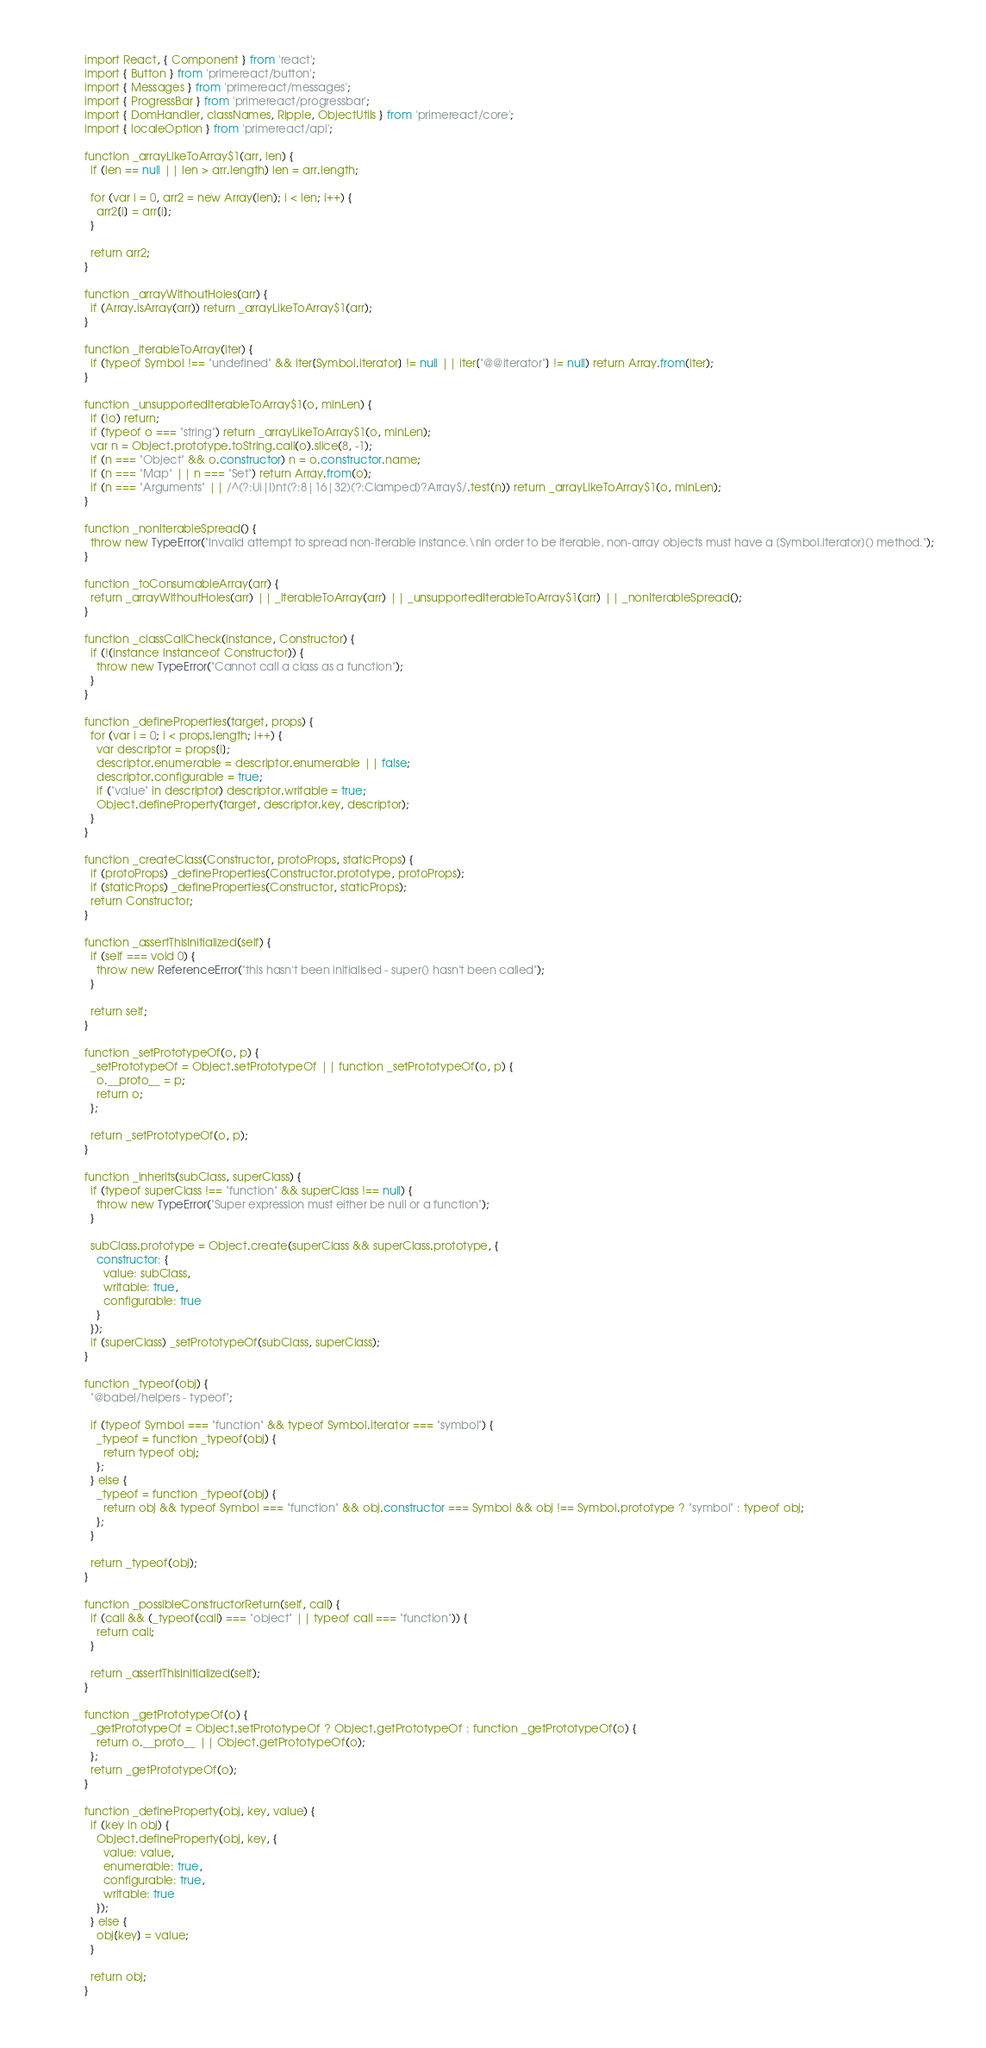<code> <loc_0><loc_0><loc_500><loc_500><_JavaScript_>import React, { Component } from 'react';
import { Button } from 'primereact/button';
import { Messages } from 'primereact/messages';
import { ProgressBar } from 'primereact/progressbar';
import { DomHandler, classNames, Ripple, ObjectUtils } from 'primereact/core';
import { localeOption } from 'primereact/api';

function _arrayLikeToArray$1(arr, len) {
  if (len == null || len > arr.length) len = arr.length;

  for (var i = 0, arr2 = new Array(len); i < len; i++) {
    arr2[i] = arr[i];
  }

  return arr2;
}

function _arrayWithoutHoles(arr) {
  if (Array.isArray(arr)) return _arrayLikeToArray$1(arr);
}

function _iterableToArray(iter) {
  if (typeof Symbol !== "undefined" && iter[Symbol.iterator] != null || iter["@@iterator"] != null) return Array.from(iter);
}

function _unsupportedIterableToArray$1(o, minLen) {
  if (!o) return;
  if (typeof o === "string") return _arrayLikeToArray$1(o, minLen);
  var n = Object.prototype.toString.call(o).slice(8, -1);
  if (n === "Object" && o.constructor) n = o.constructor.name;
  if (n === "Map" || n === "Set") return Array.from(o);
  if (n === "Arguments" || /^(?:Ui|I)nt(?:8|16|32)(?:Clamped)?Array$/.test(n)) return _arrayLikeToArray$1(o, minLen);
}

function _nonIterableSpread() {
  throw new TypeError("Invalid attempt to spread non-iterable instance.\nIn order to be iterable, non-array objects must have a [Symbol.iterator]() method.");
}

function _toConsumableArray(arr) {
  return _arrayWithoutHoles(arr) || _iterableToArray(arr) || _unsupportedIterableToArray$1(arr) || _nonIterableSpread();
}

function _classCallCheck(instance, Constructor) {
  if (!(instance instanceof Constructor)) {
    throw new TypeError("Cannot call a class as a function");
  }
}

function _defineProperties(target, props) {
  for (var i = 0; i < props.length; i++) {
    var descriptor = props[i];
    descriptor.enumerable = descriptor.enumerable || false;
    descriptor.configurable = true;
    if ("value" in descriptor) descriptor.writable = true;
    Object.defineProperty(target, descriptor.key, descriptor);
  }
}

function _createClass(Constructor, protoProps, staticProps) {
  if (protoProps) _defineProperties(Constructor.prototype, protoProps);
  if (staticProps) _defineProperties(Constructor, staticProps);
  return Constructor;
}

function _assertThisInitialized(self) {
  if (self === void 0) {
    throw new ReferenceError("this hasn't been initialised - super() hasn't been called");
  }

  return self;
}

function _setPrototypeOf(o, p) {
  _setPrototypeOf = Object.setPrototypeOf || function _setPrototypeOf(o, p) {
    o.__proto__ = p;
    return o;
  };

  return _setPrototypeOf(o, p);
}

function _inherits(subClass, superClass) {
  if (typeof superClass !== "function" && superClass !== null) {
    throw new TypeError("Super expression must either be null or a function");
  }

  subClass.prototype = Object.create(superClass && superClass.prototype, {
    constructor: {
      value: subClass,
      writable: true,
      configurable: true
    }
  });
  if (superClass) _setPrototypeOf(subClass, superClass);
}

function _typeof(obj) {
  "@babel/helpers - typeof";

  if (typeof Symbol === "function" && typeof Symbol.iterator === "symbol") {
    _typeof = function _typeof(obj) {
      return typeof obj;
    };
  } else {
    _typeof = function _typeof(obj) {
      return obj && typeof Symbol === "function" && obj.constructor === Symbol && obj !== Symbol.prototype ? "symbol" : typeof obj;
    };
  }

  return _typeof(obj);
}

function _possibleConstructorReturn(self, call) {
  if (call && (_typeof(call) === "object" || typeof call === "function")) {
    return call;
  }

  return _assertThisInitialized(self);
}

function _getPrototypeOf(o) {
  _getPrototypeOf = Object.setPrototypeOf ? Object.getPrototypeOf : function _getPrototypeOf(o) {
    return o.__proto__ || Object.getPrototypeOf(o);
  };
  return _getPrototypeOf(o);
}

function _defineProperty(obj, key, value) {
  if (key in obj) {
    Object.defineProperty(obj, key, {
      value: value,
      enumerable: true,
      configurable: true,
      writable: true
    });
  } else {
    obj[key] = value;
  }

  return obj;
}
</code> 